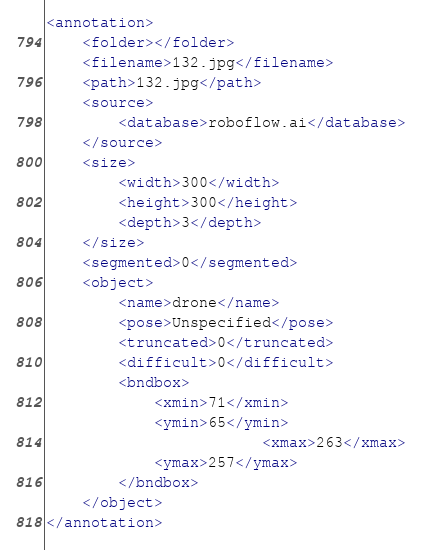Convert code to text. <code><loc_0><loc_0><loc_500><loc_500><_XML_><annotation>
	<folder></folder>
	<filename>132.jpg</filename>
	<path>132.jpg</path>
	<source>
		<database>roboflow.ai</database>
	</source>
	<size>
		<width>300</width>
		<height>300</height>
		<depth>3</depth>
	</size>
	<segmented>0</segmented>
	<object>
		<name>drone</name>
		<pose>Unspecified</pose>
		<truncated>0</truncated>
		<difficult>0</difficult>
		<bndbox>
			<xmin>71</xmin>
			<ymin>65</ymin>
                        <xmax>263</xmax>
			<ymax>257</ymax>
		</bndbox>
	</object>
</annotation>
</code> 